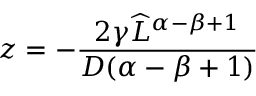Convert formula to latex. <formula><loc_0><loc_0><loc_500><loc_500>z = - \frac { 2 \gamma { \widehat { L } } ^ { \alpha - \beta + 1 } } { D ( \alpha - \beta + 1 ) }</formula> 